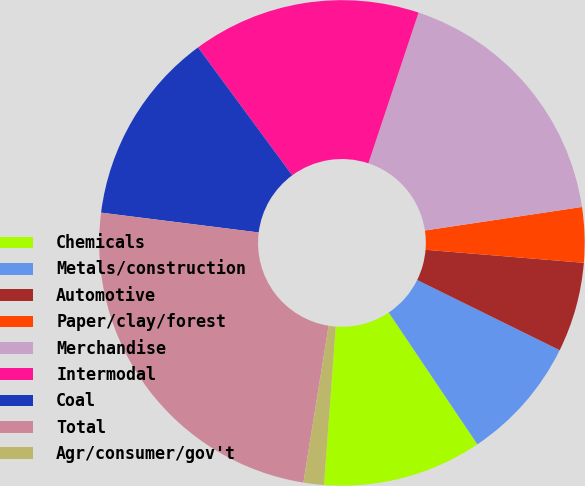<chart> <loc_0><loc_0><loc_500><loc_500><pie_chart><fcel>Chemicals<fcel>Metals/construction<fcel>Automotive<fcel>Paper/clay/forest<fcel>Merchandise<fcel>Intermodal<fcel>Coal<fcel>Total<fcel>Agr/consumer/gov't<nl><fcel>10.6%<fcel>8.29%<fcel>5.98%<fcel>3.67%<fcel>17.52%<fcel>15.21%<fcel>12.91%<fcel>24.45%<fcel>1.36%<nl></chart> 